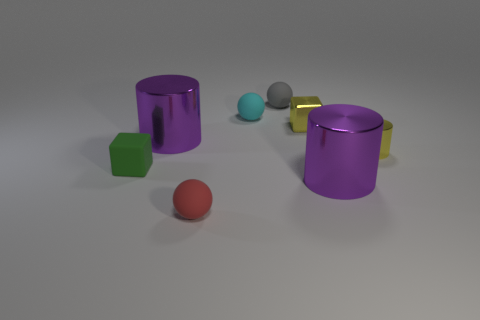Subtract all small cylinders. How many cylinders are left? 2 Subtract all cyan balls. How many balls are left? 2 Subtract 2 balls. How many balls are left? 1 Add 1 yellow shiny cylinders. How many objects exist? 9 Subtract all cubes. How many objects are left? 6 Subtract all red cylinders. Subtract all blue cubes. How many cylinders are left? 3 Subtract all cyan spheres. How many purple cubes are left? 0 Subtract all small metal objects. Subtract all small metal blocks. How many objects are left? 5 Add 2 small red matte balls. How many small red matte balls are left? 3 Add 6 big purple metallic cylinders. How many big purple metallic cylinders exist? 8 